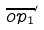<formula> <loc_0><loc_0><loc_500><loc_500>\overline { o p _ { 1 } } ^ { \prime }</formula> 